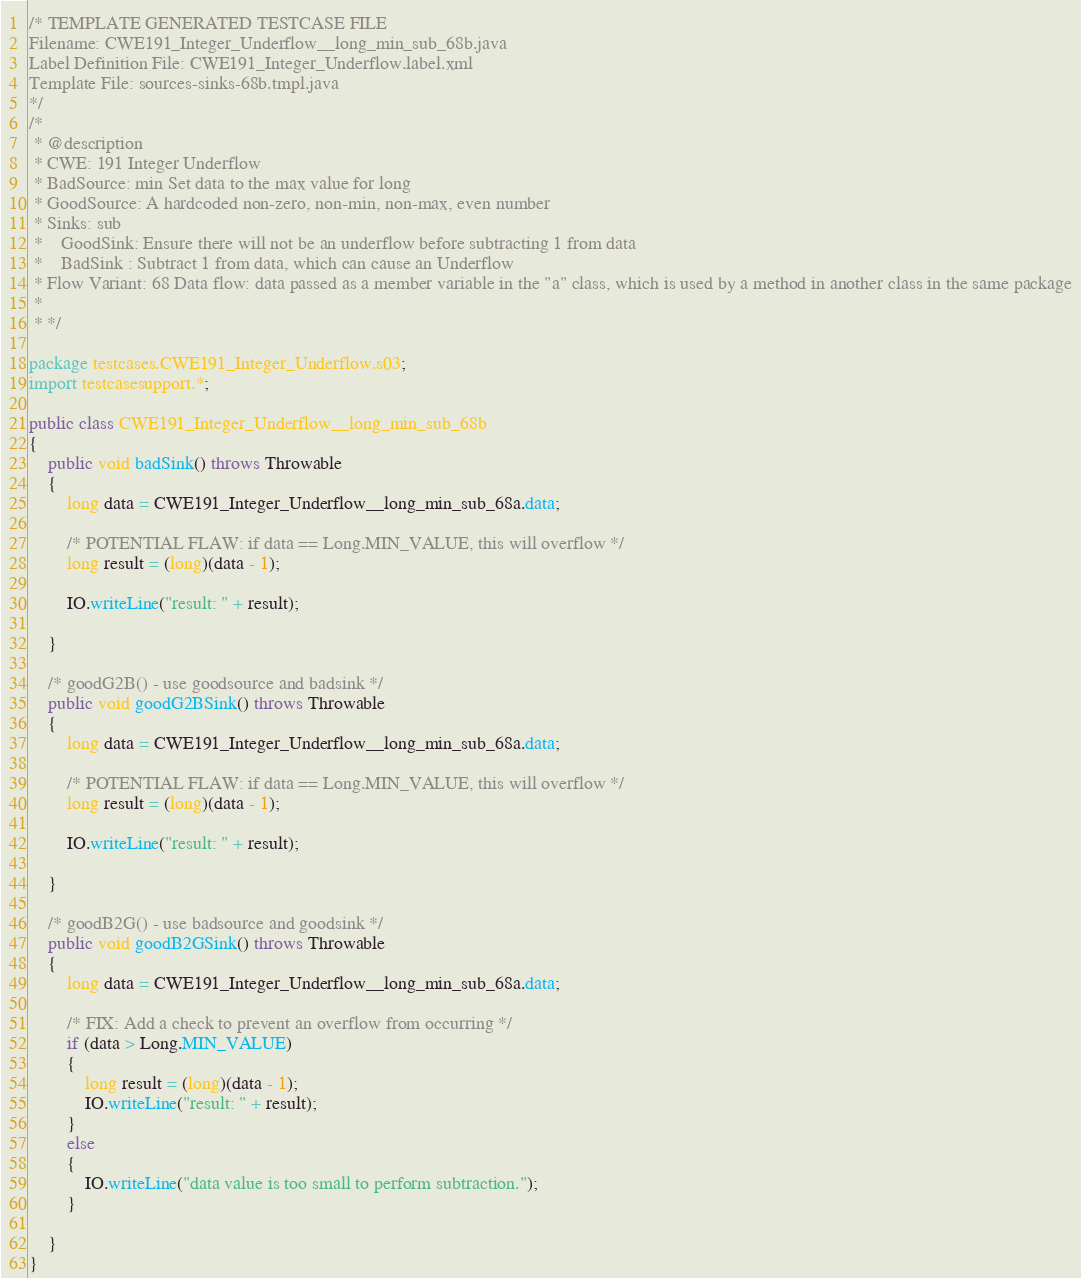Convert code to text. <code><loc_0><loc_0><loc_500><loc_500><_Java_>/* TEMPLATE GENERATED TESTCASE FILE
Filename: CWE191_Integer_Underflow__long_min_sub_68b.java
Label Definition File: CWE191_Integer_Underflow.label.xml
Template File: sources-sinks-68b.tmpl.java
*/
/*
 * @description
 * CWE: 191 Integer Underflow
 * BadSource: min Set data to the max value for long
 * GoodSource: A hardcoded non-zero, non-min, non-max, even number
 * Sinks: sub
 *    GoodSink: Ensure there will not be an underflow before subtracting 1 from data
 *    BadSink : Subtract 1 from data, which can cause an Underflow
 * Flow Variant: 68 Data flow: data passed as a member variable in the "a" class, which is used by a method in another class in the same package
 *
 * */

package testcases.CWE191_Integer_Underflow.s03;
import testcasesupport.*;

public class CWE191_Integer_Underflow__long_min_sub_68b
{
    public void badSink() throws Throwable
    {
        long data = CWE191_Integer_Underflow__long_min_sub_68a.data;

        /* POTENTIAL FLAW: if data == Long.MIN_VALUE, this will overflow */
        long result = (long)(data - 1);

        IO.writeLine("result: " + result);

    }

    /* goodG2B() - use goodsource and badsink */
    public void goodG2BSink() throws Throwable
    {
        long data = CWE191_Integer_Underflow__long_min_sub_68a.data;

        /* POTENTIAL FLAW: if data == Long.MIN_VALUE, this will overflow */
        long result = (long)(data - 1);

        IO.writeLine("result: " + result);

    }

    /* goodB2G() - use badsource and goodsink */
    public void goodB2GSink() throws Throwable
    {
        long data = CWE191_Integer_Underflow__long_min_sub_68a.data;

        /* FIX: Add a check to prevent an overflow from occurring */
        if (data > Long.MIN_VALUE)
        {
            long result = (long)(data - 1);
            IO.writeLine("result: " + result);
        }
        else
        {
            IO.writeLine("data value is too small to perform subtraction.");
        }

    }
}
</code> 